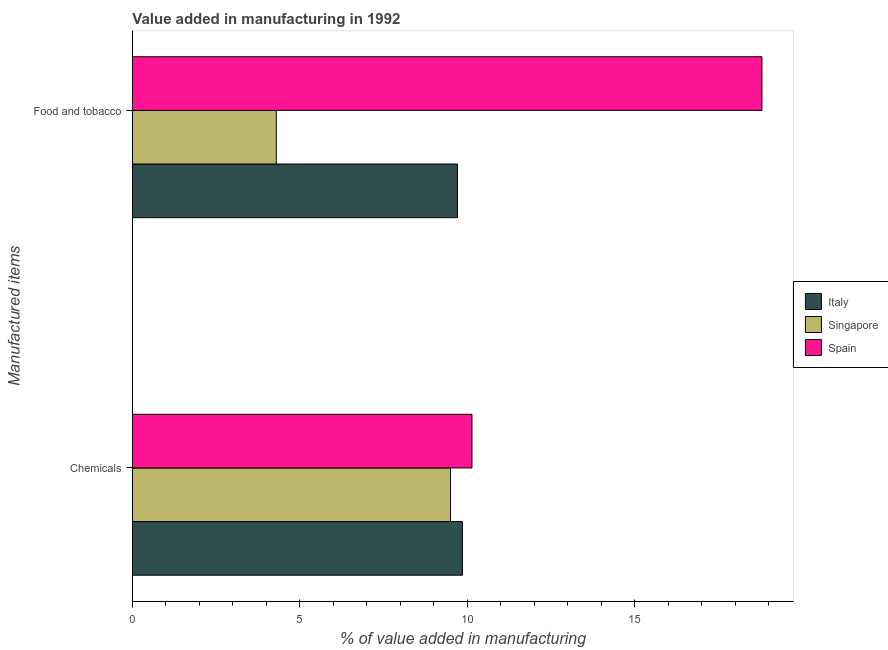How many different coloured bars are there?
Provide a short and direct response. 3. Are the number of bars per tick equal to the number of legend labels?
Your response must be concise. Yes. Are the number of bars on each tick of the Y-axis equal?
Keep it short and to the point. Yes. How many bars are there on the 1st tick from the top?
Keep it short and to the point. 3. How many bars are there on the 1st tick from the bottom?
Keep it short and to the point. 3. What is the label of the 1st group of bars from the top?
Make the answer very short. Food and tobacco. What is the value added by manufacturing food and tobacco in Singapore?
Your answer should be very brief. 4.3. Across all countries, what is the maximum value added by manufacturing food and tobacco?
Give a very brief answer. 18.8. Across all countries, what is the minimum value added by manufacturing food and tobacco?
Offer a terse response. 4.3. In which country was the value added by manufacturing food and tobacco maximum?
Your answer should be very brief. Spain. In which country was the value added by  manufacturing chemicals minimum?
Offer a very short reply. Singapore. What is the total value added by manufacturing food and tobacco in the graph?
Your response must be concise. 32.8. What is the difference between the value added by manufacturing food and tobacco in Spain and that in Singapore?
Your response must be concise. 14.5. What is the difference between the value added by  manufacturing chemicals in Spain and the value added by manufacturing food and tobacco in Italy?
Ensure brevity in your answer.  0.43. What is the average value added by manufacturing food and tobacco per country?
Offer a terse response. 10.93. What is the difference between the value added by manufacturing food and tobacco and value added by  manufacturing chemicals in Italy?
Offer a terse response. -0.15. What is the ratio of the value added by manufacturing food and tobacco in Spain to that in Singapore?
Your answer should be very brief. 4.38. Is the value added by  manufacturing chemicals in Singapore less than that in Italy?
Provide a short and direct response. Yes. In how many countries, is the value added by manufacturing food and tobacco greater than the average value added by manufacturing food and tobacco taken over all countries?
Ensure brevity in your answer.  1. What does the 1st bar from the bottom in Food and tobacco represents?
Provide a short and direct response. Italy. How many bars are there?
Your response must be concise. 6. How many countries are there in the graph?
Ensure brevity in your answer.  3. What is the difference between two consecutive major ticks on the X-axis?
Your answer should be compact. 5. Does the graph contain grids?
Provide a succinct answer. No. Where does the legend appear in the graph?
Offer a terse response. Center right. How many legend labels are there?
Make the answer very short. 3. What is the title of the graph?
Offer a terse response. Value added in manufacturing in 1992. Does "Russian Federation" appear as one of the legend labels in the graph?
Your answer should be compact. No. What is the label or title of the X-axis?
Your response must be concise. % of value added in manufacturing. What is the label or title of the Y-axis?
Give a very brief answer. Manufactured items. What is the % of value added in manufacturing in Italy in Chemicals?
Your answer should be very brief. 9.85. What is the % of value added in manufacturing of Singapore in Chemicals?
Ensure brevity in your answer.  9.5. What is the % of value added in manufacturing of Spain in Chemicals?
Your answer should be very brief. 10.14. What is the % of value added in manufacturing of Italy in Food and tobacco?
Provide a short and direct response. 9.71. What is the % of value added in manufacturing of Singapore in Food and tobacco?
Offer a very short reply. 4.3. What is the % of value added in manufacturing of Spain in Food and tobacco?
Offer a terse response. 18.8. Across all Manufactured items, what is the maximum % of value added in manufacturing of Italy?
Make the answer very short. 9.85. Across all Manufactured items, what is the maximum % of value added in manufacturing in Singapore?
Provide a succinct answer. 9.5. Across all Manufactured items, what is the maximum % of value added in manufacturing of Spain?
Give a very brief answer. 18.8. Across all Manufactured items, what is the minimum % of value added in manufacturing of Italy?
Your response must be concise. 9.71. Across all Manufactured items, what is the minimum % of value added in manufacturing in Singapore?
Give a very brief answer. 4.3. Across all Manufactured items, what is the minimum % of value added in manufacturing of Spain?
Your answer should be compact. 10.14. What is the total % of value added in manufacturing of Italy in the graph?
Give a very brief answer. 19.56. What is the total % of value added in manufacturing of Singapore in the graph?
Ensure brevity in your answer.  13.79. What is the total % of value added in manufacturing of Spain in the graph?
Provide a succinct answer. 28.94. What is the difference between the % of value added in manufacturing of Italy in Chemicals and that in Food and tobacco?
Provide a succinct answer. 0.15. What is the difference between the % of value added in manufacturing in Singapore in Chemicals and that in Food and tobacco?
Your answer should be very brief. 5.2. What is the difference between the % of value added in manufacturing of Spain in Chemicals and that in Food and tobacco?
Give a very brief answer. -8.66. What is the difference between the % of value added in manufacturing of Italy in Chemicals and the % of value added in manufacturing of Singapore in Food and tobacco?
Provide a succinct answer. 5.56. What is the difference between the % of value added in manufacturing in Italy in Chemicals and the % of value added in manufacturing in Spain in Food and tobacco?
Your response must be concise. -8.94. What is the difference between the % of value added in manufacturing of Singapore in Chemicals and the % of value added in manufacturing of Spain in Food and tobacco?
Provide a short and direct response. -9.3. What is the average % of value added in manufacturing in Italy per Manufactured items?
Provide a succinct answer. 9.78. What is the average % of value added in manufacturing in Singapore per Manufactured items?
Keep it short and to the point. 6.9. What is the average % of value added in manufacturing in Spain per Manufactured items?
Ensure brevity in your answer.  14.47. What is the difference between the % of value added in manufacturing of Italy and % of value added in manufacturing of Singapore in Chemicals?
Offer a terse response. 0.36. What is the difference between the % of value added in manufacturing of Italy and % of value added in manufacturing of Spain in Chemicals?
Your answer should be compact. -0.28. What is the difference between the % of value added in manufacturing of Singapore and % of value added in manufacturing of Spain in Chemicals?
Keep it short and to the point. -0.64. What is the difference between the % of value added in manufacturing of Italy and % of value added in manufacturing of Singapore in Food and tobacco?
Offer a very short reply. 5.41. What is the difference between the % of value added in manufacturing of Italy and % of value added in manufacturing of Spain in Food and tobacco?
Your response must be concise. -9.09. What is the difference between the % of value added in manufacturing of Singapore and % of value added in manufacturing of Spain in Food and tobacco?
Your answer should be compact. -14.5. What is the ratio of the % of value added in manufacturing in Italy in Chemicals to that in Food and tobacco?
Provide a succinct answer. 1.02. What is the ratio of the % of value added in manufacturing in Singapore in Chemicals to that in Food and tobacco?
Give a very brief answer. 2.21. What is the ratio of the % of value added in manufacturing of Spain in Chemicals to that in Food and tobacco?
Your answer should be very brief. 0.54. What is the difference between the highest and the second highest % of value added in manufacturing in Italy?
Provide a short and direct response. 0.15. What is the difference between the highest and the second highest % of value added in manufacturing of Singapore?
Your answer should be very brief. 5.2. What is the difference between the highest and the second highest % of value added in manufacturing in Spain?
Give a very brief answer. 8.66. What is the difference between the highest and the lowest % of value added in manufacturing in Italy?
Offer a terse response. 0.15. What is the difference between the highest and the lowest % of value added in manufacturing of Singapore?
Your answer should be compact. 5.2. What is the difference between the highest and the lowest % of value added in manufacturing in Spain?
Make the answer very short. 8.66. 